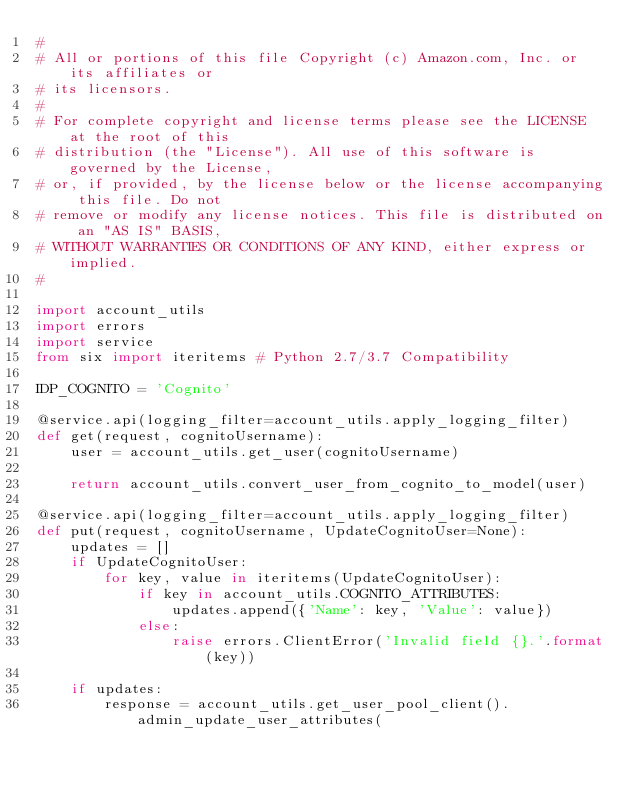<code> <loc_0><loc_0><loc_500><loc_500><_Python_>#
# All or portions of this file Copyright (c) Amazon.com, Inc. or its affiliates or
# its licensors.
#
# For complete copyright and license terms please see the LICENSE at the root of this
# distribution (the "License"). All use of this software is governed by the License,
# or, if provided, by the license below or the license accompanying this file. Do not
# remove or modify any license notices. This file is distributed on an "AS IS" BASIS,
# WITHOUT WARRANTIES OR CONDITIONS OF ANY KIND, either express or implied.
#

import account_utils
import errors
import service
from six import iteritems # Python 2.7/3.7 Compatibility

IDP_COGNITO = 'Cognito'

@service.api(logging_filter=account_utils.apply_logging_filter)
def get(request, cognitoUsername):
    user = account_utils.get_user(cognitoUsername)

    return account_utils.convert_user_from_cognito_to_model(user)

@service.api(logging_filter=account_utils.apply_logging_filter)
def put(request, cognitoUsername, UpdateCognitoUser=None):
    updates = []
    if UpdateCognitoUser:
        for key, value in iteritems(UpdateCognitoUser):
            if key in account_utils.COGNITO_ATTRIBUTES:
                updates.append({'Name': key, 'Value': value})
            else:
                raise errors.ClientError('Invalid field {}.'.format(key))

    if updates:
        response = account_utils.get_user_pool_client().admin_update_user_attributes(</code> 